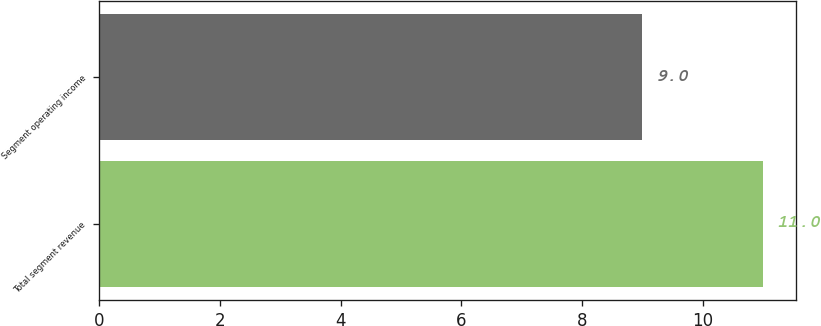<chart> <loc_0><loc_0><loc_500><loc_500><bar_chart><fcel>Total segment revenue<fcel>Segment operating income<nl><fcel>11<fcel>9<nl></chart> 